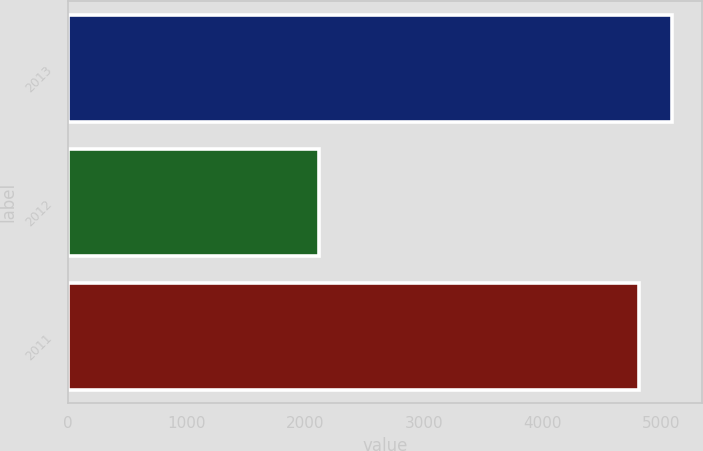Convert chart. <chart><loc_0><loc_0><loc_500><loc_500><bar_chart><fcel>2013<fcel>2012<fcel>2011<nl><fcel>5087.3<fcel>2117<fcel>4806<nl></chart> 